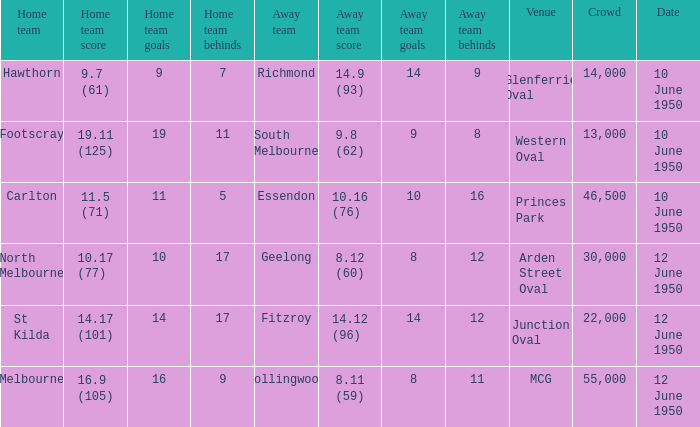What was the crowd when the VFL played MCG? 55000.0. 